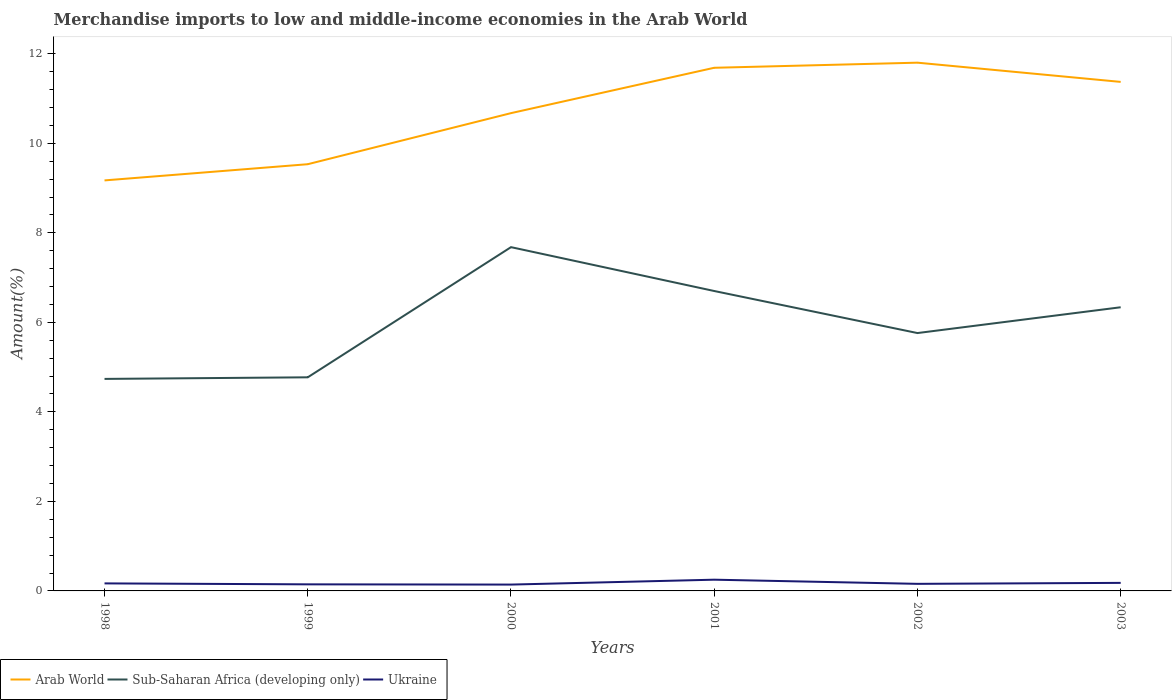How many different coloured lines are there?
Keep it short and to the point. 3. Is the number of lines equal to the number of legend labels?
Offer a very short reply. Yes. Across all years, what is the maximum percentage of amount earned from merchandise imports in Sub-Saharan Africa (developing only)?
Provide a succinct answer. 4.74. In which year was the percentage of amount earned from merchandise imports in Ukraine maximum?
Offer a very short reply. 2000. What is the total percentage of amount earned from merchandise imports in Ukraine in the graph?
Make the answer very short. -0.11. What is the difference between the highest and the second highest percentage of amount earned from merchandise imports in Arab World?
Offer a terse response. 2.63. What is the difference between the highest and the lowest percentage of amount earned from merchandise imports in Ukraine?
Your answer should be very brief. 2. Is the percentage of amount earned from merchandise imports in Arab World strictly greater than the percentage of amount earned from merchandise imports in Ukraine over the years?
Ensure brevity in your answer.  No. How many lines are there?
Give a very brief answer. 3. Are the values on the major ticks of Y-axis written in scientific E-notation?
Offer a terse response. No. Does the graph contain any zero values?
Ensure brevity in your answer.  No. What is the title of the graph?
Provide a succinct answer. Merchandise imports to low and middle-income economies in the Arab World. What is the label or title of the X-axis?
Your answer should be very brief. Years. What is the label or title of the Y-axis?
Offer a very short reply. Amount(%). What is the Amount(%) in Arab World in 1998?
Offer a terse response. 9.17. What is the Amount(%) in Sub-Saharan Africa (developing only) in 1998?
Your answer should be very brief. 4.74. What is the Amount(%) of Ukraine in 1998?
Give a very brief answer. 0.17. What is the Amount(%) of Arab World in 1999?
Offer a terse response. 9.53. What is the Amount(%) in Sub-Saharan Africa (developing only) in 1999?
Give a very brief answer. 4.77. What is the Amount(%) in Ukraine in 1999?
Offer a terse response. 0.15. What is the Amount(%) of Arab World in 2000?
Offer a terse response. 10.68. What is the Amount(%) of Sub-Saharan Africa (developing only) in 2000?
Make the answer very short. 7.68. What is the Amount(%) in Ukraine in 2000?
Your answer should be compact. 0.14. What is the Amount(%) of Arab World in 2001?
Provide a short and direct response. 11.69. What is the Amount(%) of Sub-Saharan Africa (developing only) in 2001?
Keep it short and to the point. 6.7. What is the Amount(%) of Ukraine in 2001?
Ensure brevity in your answer.  0.25. What is the Amount(%) in Arab World in 2002?
Offer a very short reply. 11.8. What is the Amount(%) of Sub-Saharan Africa (developing only) in 2002?
Your answer should be very brief. 5.76. What is the Amount(%) in Ukraine in 2002?
Give a very brief answer. 0.16. What is the Amount(%) in Arab World in 2003?
Your response must be concise. 11.37. What is the Amount(%) in Sub-Saharan Africa (developing only) in 2003?
Your answer should be very brief. 6.34. What is the Amount(%) in Ukraine in 2003?
Ensure brevity in your answer.  0.18. Across all years, what is the maximum Amount(%) in Arab World?
Offer a terse response. 11.8. Across all years, what is the maximum Amount(%) of Sub-Saharan Africa (developing only)?
Offer a terse response. 7.68. Across all years, what is the maximum Amount(%) in Ukraine?
Give a very brief answer. 0.25. Across all years, what is the minimum Amount(%) of Arab World?
Your response must be concise. 9.17. Across all years, what is the minimum Amount(%) in Sub-Saharan Africa (developing only)?
Give a very brief answer. 4.74. Across all years, what is the minimum Amount(%) in Ukraine?
Your answer should be compact. 0.14. What is the total Amount(%) of Arab World in the graph?
Provide a succinct answer. 64.25. What is the total Amount(%) in Sub-Saharan Africa (developing only) in the graph?
Give a very brief answer. 35.99. What is the total Amount(%) of Ukraine in the graph?
Your answer should be compact. 1.05. What is the difference between the Amount(%) of Arab World in 1998 and that in 1999?
Your answer should be very brief. -0.36. What is the difference between the Amount(%) of Sub-Saharan Africa (developing only) in 1998 and that in 1999?
Your answer should be very brief. -0.04. What is the difference between the Amount(%) in Ukraine in 1998 and that in 1999?
Offer a very short reply. 0.02. What is the difference between the Amount(%) of Arab World in 1998 and that in 2000?
Give a very brief answer. -1.5. What is the difference between the Amount(%) of Sub-Saharan Africa (developing only) in 1998 and that in 2000?
Make the answer very short. -2.94. What is the difference between the Amount(%) in Ukraine in 1998 and that in 2000?
Offer a terse response. 0.03. What is the difference between the Amount(%) in Arab World in 1998 and that in 2001?
Your answer should be compact. -2.52. What is the difference between the Amount(%) in Sub-Saharan Africa (developing only) in 1998 and that in 2001?
Offer a very short reply. -1.96. What is the difference between the Amount(%) of Ukraine in 1998 and that in 2001?
Your answer should be compact. -0.08. What is the difference between the Amount(%) of Arab World in 1998 and that in 2002?
Offer a very short reply. -2.63. What is the difference between the Amount(%) in Sub-Saharan Africa (developing only) in 1998 and that in 2002?
Give a very brief answer. -1.02. What is the difference between the Amount(%) of Ukraine in 1998 and that in 2002?
Give a very brief answer. 0.01. What is the difference between the Amount(%) of Arab World in 1998 and that in 2003?
Your answer should be very brief. -2.2. What is the difference between the Amount(%) of Sub-Saharan Africa (developing only) in 1998 and that in 2003?
Your answer should be very brief. -1.6. What is the difference between the Amount(%) in Ukraine in 1998 and that in 2003?
Provide a short and direct response. -0.01. What is the difference between the Amount(%) of Arab World in 1999 and that in 2000?
Offer a terse response. -1.14. What is the difference between the Amount(%) of Sub-Saharan Africa (developing only) in 1999 and that in 2000?
Your response must be concise. -2.91. What is the difference between the Amount(%) of Ukraine in 1999 and that in 2000?
Keep it short and to the point. 0.01. What is the difference between the Amount(%) in Arab World in 1999 and that in 2001?
Your answer should be very brief. -2.15. What is the difference between the Amount(%) of Sub-Saharan Africa (developing only) in 1999 and that in 2001?
Your response must be concise. -1.93. What is the difference between the Amount(%) in Ukraine in 1999 and that in 2001?
Your response must be concise. -0.1. What is the difference between the Amount(%) in Arab World in 1999 and that in 2002?
Your answer should be compact. -2.27. What is the difference between the Amount(%) of Sub-Saharan Africa (developing only) in 1999 and that in 2002?
Give a very brief answer. -0.99. What is the difference between the Amount(%) in Ukraine in 1999 and that in 2002?
Make the answer very short. -0.01. What is the difference between the Amount(%) in Arab World in 1999 and that in 2003?
Your answer should be very brief. -1.84. What is the difference between the Amount(%) in Sub-Saharan Africa (developing only) in 1999 and that in 2003?
Ensure brevity in your answer.  -1.57. What is the difference between the Amount(%) of Ukraine in 1999 and that in 2003?
Your answer should be very brief. -0.03. What is the difference between the Amount(%) of Arab World in 2000 and that in 2001?
Offer a terse response. -1.01. What is the difference between the Amount(%) of Sub-Saharan Africa (developing only) in 2000 and that in 2001?
Provide a succinct answer. 0.98. What is the difference between the Amount(%) in Ukraine in 2000 and that in 2001?
Keep it short and to the point. -0.11. What is the difference between the Amount(%) of Arab World in 2000 and that in 2002?
Your response must be concise. -1.13. What is the difference between the Amount(%) of Sub-Saharan Africa (developing only) in 2000 and that in 2002?
Offer a very short reply. 1.92. What is the difference between the Amount(%) of Ukraine in 2000 and that in 2002?
Provide a short and direct response. -0.02. What is the difference between the Amount(%) of Arab World in 2000 and that in 2003?
Your answer should be very brief. -0.7. What is the difference between the Amount(%) of Sub-Saharan Africa (developing only) in 2000 and that in 2003?
Provide a short and direct response. 1.34. What is the difference between the Amount(%) of Ukraine in 2000 and that in 2003?
Your answer should be very brief. -0.04. What is the difference between the Amount(%) of Arab World in 2001 and that in 2002?
Keep it short and to the point. -0.11. What is the difference between the Amount(%) of Sub-Saharan Africa (developing only) in 2001 and that in 2002?
Your answer should be very brief. 0.94. What is the difference between the Amount(%) in Ukraine in 2001 and that in 2002?
Ensure brevity in your answer.  0.09. What is the difference between the Amount(%) of Arab World in 2001 and that in 2003?
Your answer should be compact. 0.32. What is the difference between the Amount(%) in Sub-Saharan Africa (developing only) in 2001 and that in 2003?
Make the answer very short. 0.36. What is the difference between the Amount(%) of Ukraine in 2001 and that in 2003?
Offer a very short reply. 0.07. What is the difference between the Amount(%) of Arab World in 2002 and that in 2003?
Give a very brief answer. 0.43. What is the difference between the Amount(%) of Sub-Saharan Africa (developing only) in 2002 and that in 2003?
Provide a succinct answer. -0.58. What is the difference between the Amount(%) of Ukraine in 2002 and that in 2003?
Ensure brevity in your answer.  -0.02. What is the difference between the Amount(%) of Arab World in 1998 and the Amount(%) of Sub-Saharan Africa (developing only) in 1999?
Offer a terse response. 4.4. What is the difference between the Amount(%) in Arab World in 1998 and the Amount(%) in Ukraine in 1999?
Provide a short and direct response. 9.03. What is the difference between the Amount(%) of Sub-Saharan Africa (developing only) in 1998 and the Amount(%) of Ukraine in 1999?
Provide a short and direct response. 4.59. What is the difference between the Amount(%) of Arab World in 1998 and the Amount(%) of Sub-Saharan Africa (developing only) in 2000?
Your answer should be compact. 1.49. What is the difference between the Amount(%) of Arab World in 1998 and the Amount(%) of Ukraine in 2000?
Provide a short and direct response. 9.03. What is the difference between the Amount(%) of Sub-Saharan Africa (developing only) in 1998 and the Amount(%) of Ukraine in 2000?
Provide a succinct answer. 4.6. What is the difference between the Amount(%) of Arab World in 1998 and the Amount(%) of Sub-Saharan Africa (developing only) in 2001?
Your answer should be very brief. 2.47. What is the difference between the Amount(%) of Arab World in 1998 and the Amount(%) of Ukraine in 2001?
Make the answer very short. 8.92. What is the difference between the Amount(%) of Sub-Saharan Africa (developing only) in 1998 and the Amount(%) of Ukraine in 2001?
Your answer should be very brief. 4.49. What is the difference between the Amount(%) in Arab World in 1998 and the Amount(%) in Sub-Saharan Africa (developing only) in 2002?
Your response must be concise. 3.41. What is the difference between the Amount(%) of Arab World in 1998 and the Amount(%) of Ukraine in 2002?
Provide a succinct answer. 9.01. What is the difference between the Amount(%) of Sub-Saharan Africa (developing only) in 1998 and the Amount(%) of Ukraine in 2002?
Keep it short and to the point. 4.58. What is the difference between the Amount(%) in Arab World in 1998 and the Amount(%) in Sub-Saharan Africa (developing only) in 2003?
Offer a very short reply. 2.83. What is the difference between the Amount(%) of Arab World in 1998 and the Amount(%) of Ukraine in 2003?
Provide a succinct answer. 8.99. What is the difference between the Amount(%) in Sub-Saharan Africa (developing only) in 1998 and the Amount(%) in Ukraine in 2003?
Provide a short and direct response. 4.56. What is the difference between the Amount(%) in Arab World in 1999 and the Amount(%) in Sub-Saharan Africa (developing only) in 2000?
Your answer should be compact. 1.85. What is the difference between the Amount(%) of Arab World in 1999 and the Amount(%) of Ukraine in 2000?
Provide a short and direct response. 9.39. What is the difference between the Amount(%) in Sub-Saharan Africa (developing only) in 1999 and the Amount(%) in Ukraine in 2000?
Offer a very short reply. 4.63. What is the difference between the Amount(%) in Arab World in 1999 and the Amount(%) in Sub-Saharan Africa (developing only) in 2001?
Keep it short and to the point. 2.83. What is the difference between the Amount(%) of Arab World in 1999 and the Amount(%) of Ukraine in 2001?
Keep it short and to the point. 9.28. What is the difference between the Amount(%) in Sub-Saharan Africa (developing only) in 1999 and the Amount(%) in Ukraine in 2001?
Offer a very short reply. 4.52. What is the difference between the Amount(%) in Arab World in 1999 and the Amount(%) in Sub-Saharan Africa (developing only) in 2002?
Offer a terse response. 3.77. What is the difference between the Amount(%) of Arab World in 1999 and the Amount(%) of Ukraine in 2002?
Ensure brevity in your answer.  9.38. What is the difference between the Amount(%) of Sub-Saharan Africa (developing only) in 1999 and the Amount(%) of Ukraine in 2002?
Give a very brief answer. 4.61. What is the difference between the Amount(%) of Arab World in 1999 and the Amount(%) of Sub-Saharan Africa (developing only) in 2003?
Your answer should be very brief. 3.2. What is the difference between the Amount(%) in Arab World in 1999 and the Amount(%) in Ukraine in 2003?
Make the answer very short. 9.35. What is the difference between the Amount(%) of Sub-Saharan Africa (developing only) in 1999 and the Amount(%) of Ukraine in 2003?
Give a very brief answer. 4.59. What is the difference between the Amount(%) of Arab World in 2000 and the Amount(%) of Sub-Saharan Africa (developing only) in 2001?
Provide a succinct answer. 3.97. What is the difference between the Amount(%) in Arab World in 2000 and the Amount(%) in Ukraine in 2001?
Give a very brief answer. 10.42. What is the difference between the Amount(%) in Sub-Saharan Africa (developing only) in 2000 and the Amount(%) in Ukraine in 2001?
Give a very brief answer. 7.43. What is the difference between the Amount(%) in Arab World in 2000 and the Amount(%) in Sub-Saharan Africa (developing only) in 2002?
Offer a terse response. 4.91. What is the difference between the Amount(%) in Arab World in 2000 and the Amount(%) in Ukraine in 2002?
Make the answer very short. 10.52. What is the difference between the Amount(%) of Sub-Saharan Africa (developing only) in 2000 and the Amount(%) of Ukraine in 2002?
Offer a very short reply. 7.52. What is the difference between the Amount(%) in Arab World in 2000 and the Amount(%) in Sub-Saharan Africa (developing only) in 2003?
Make the answer very short. 4.34. What is the difference between the Amount(%) in Arab World in 2000 and the Amount(%) in Ukraine in 2003?
Provide a succinct answer. 10.5. What is the difference between the Amount(%) in Sub-Saharan Africa (developing only) in 2000 and the Amount(%) in Ukraine in 2003?
Offer a terse response. 7.5. What is the difference between the Amount(%) in Arab World in 2001 and the Amount(%) in Sub-Saharan Africa (developing only) in 2002?
Your answer should be compact. 5.93. What is the difference between the Amount(%) in Arab World in 2001 and the Amount(%) in Ukraine in 2002?
Ensure brevity in your answer.  11.53. What is the difference between the Amount(%) of Sub-Saharan Africa (developing only) in 2001 and the Amount(%) of Ukraine in 2002?
Provide a succinct answer. 6.54. What is the difference between the Amount(%) in Arab World in 2001 and the Amount(%) in Sub-Saharan Africa (developing only) in 2003?
Your response must be concise. 5.35. What is the difference between the Amount(%) of Arab World in 2001 and the Amount(%) of Ukraine in 2003?
Make the answer very short. 11.51. What is the difference between the Amount(%) in Sub-Saharan Africa (developing only) in 2001 and the Amount(%) in Ukraine in 2003?
Give a very brief answer. 6.52. What is the difference between the Amount(%) of Arab World in 2002 and the Amount(%) of Sub-Saharan Africa (developing only) in 2003?
Give a very brief answer. 5.46. What is the difference between the Amount(%) in Arab World in 2002 and the Amount(%) in Ukraine in 2003?
Your response must be concise. 11.62. What is the difference between the Amount(%) of Sub-Saharan Africa (developing only) in 2002 and the Amount(%) of Ukraine in 2003?
Your response must be concise. 5.58. What is the average Amount(%) in Arab World per year?
Give a very brief answer. 10.71. What is the average Amount(%) of Sub-Saharan Africa (developing only) per year?
Give a very brief answer. 6. What is the average Amount(%) of Ukraine per year?
Give a very brief answer. 0.17. In the year 1998, what is the difference between the Amount(%) in Arab World and Amount(%) in Sub-Saharan Africa (developing only)?
Give a very brief answer. 4.44. In the year 1998, what is the difference between the Amount(%) of Arab World and Amount(%) of Ukraine?
Your answer should be very brief. 9. In the year 1998, what is the difference between the Amount(%) in Sub-Saharan Africa (developing only) and Amount(%) in Ukraine?
Offer a very short reply. 4.57. In the year 1999, what is the difference between the Amount(%) of Arab World and Amount(%) of Sub-Saharan Africa (developing only)?
Make the answer very short. 4.76. In the year 1999, what is the difference between the Amount(%) of Arab World and Amount(%) of Ukraine?
Your answer should be very brief. 9.39. In the year 1999, what is the difference between the Amount(%) in Sub-Saharan Africa (developing only) and Amount(%) in Ukraine?
Your answer should be very brief. 4.63. In the year 2000, what is the difference between the Amount(%) in Arab World and Amount(%) in Sub-Saharan Africa (developing only)?
Your answer should be very brief. 2.99. In the year 2000, what is the difference between the Amount(%) in Arab World and Amount(%) in Ukraine?
Make the answer very short. 10.53. In the year 2000, what is the difference between the Amount(%) in Sub-Saharan Africa (developing only) and Amount(%) in Ukraine?
Provide a succinct answer. 7.54. In the year 2001, what is the difference between the Amount(%) in Arab World and Amount(%) in Sub-Saharan Africa (developing only)?
Offer a terse response. 4.99. In the year 2001, what is the difference between the Amount(%) in Arab World and Amount(%) in Ukraine?
Provide a succinct answer. 11.44. In the year 2001, what is the difference between the Amount(%) in Sub-Saharan Africa (developing only) and Amount(%) in Ukraine?
Give a very brief answer. 6.45. In the year 2002, what is the difference between the Amount(%) in Arab World and Amount(%) in Sub-Saharan Africa (developing only)?
Offer a terse response. 6.04. In the year 2002, what is the difference between the Amount(%) in Arab World and Amount(%) in Ukraine?
Provide a short and direct response. 11.64. In the year 2002, what is the difference between the Amount(%) in Sub-Saharan Africa (developing only) and Amount(%) in Ukraine?
Provide a short and direct response. 5.6. In the year 2003, what is the difference between the Amount(%) of Arab World and Amount(%) of Sub-Saharan Africa (developing only)?
Make the answer very short. 5.04. In the year 2003, what is the difference between the Amount(%) in Arab World and Amount(%) in Ukraine?
Make the answer very short. 11.19. In the year 2003, what is the difference between the Amount(%) in Sub-Saharan Africa (developing only) and Amount(%) in Ukraine?
Provide a succinct answer. 6.16. What is the ratio of the Amount(%) in Sub-Saharan Africa (developing only) in 1998 to that in 1999?
Make the answer very short. 0.99. What is the ratio of the Amount(%) of Ukraine in 1998 to that in 1999?
Your answer should be compact. 1.15. What is the ratio of the Amount(%) of Arab World in 1998 to that in 2000?
Offer a terse response. 0.86. What is the ratio of the Amount(%) of Sub-Saharan Africa (developing only) in 1998 to that in 2000?
Give a very brief answer. 0.62. What is the ratio of the Amount(%) in Ukraine in 1998 to that in 2000?
Ensure brevity in your answer.  1.19. What is the ratio of the Amount(%) in Arab World in 1998 to that in 2001?
Give a very brief answer. 0.78. What is the ratio of the Amount(%) of Sub-Saharan Africa (developing only) in 1998 to that in 2001?
Provide a short and direct response. 0.71. What is the ratio of the Amount(%) in Ukraine in 1998 to that in 2001?
Offer a terse response. 0.67. What is the ratio of the Amount(%) of Arab World in 1998 to that in 2002?
Offer a terse response. 0.78. What is the ratio of the Amount(%) of Sub-Saharan Africa (developing only) in 1998 to that in 2002?
Your answer should be compact. 0.82. What is the ratio of the Amount(%) of Ukraine in 1998 to that in 2002?
Keep it short and to the point. 1.06. What is the ratio of the Amount(%) of Arab World in 1998 to that in 2003?
Keep it short and to the point. 0.81. What is the ratio of the Amount(%) of Sub-Saharan Africa (developing only) in 1998 to that in 2003?
Offer a terse response. 0.75. What is the ratio of the Amount(%) in Ukraine in 1998 to that in 2003?
Provide a short and direct response. 0.94. What is the ratio of the Amount(%) in Arab World in 1999 to that in 2000?
Your answer should be very brief. 0.89. What is the ratio of the Amount(%) of Sub-Saharan Africa (developing only) in 1999 to that in 2000?
Provide a short and direct response. 0.62. What is the ratio of the Amount(%) in Ukraine in 1999 to that in 2000?
Ensure brevity in your answer.  1.04. What is the ratio of the Amount(%) in Arab World in 1999 to that in 2001?
Offer a terse response. 0.82. What is the ratio of the Amount(%) in Sub-Saharan Africa (developing only) in 1999 to that in 2001?
Your answer should be very brief. 0.71. What is the ratio of the Amount(%) of Ukraine in 1999 to that in 2001?
Your answer should be very brief. 0.58. What is the ratio of the Amount(%) of Arab World in 1999 to that in 2002?
Offer a terse response. 0.81. What is the ratio of the Amount(%) in Sub-Saharan Africa (developing only) in 1999 to that in 2002?
Your answer should be very brief. 0.83. What is the ratio of the Amount(%) in Ukraine in 1999 to that in 2002?
Give a very brief answer. 0.93. What is the ratio of the Amount(%) of Arab World in 1999 to that in 2003?
Your answer should be very brief. 0.84. What is the ratio of the Amount(%) in Sub-Saharan Africa (developing only) in 1999 to that in 2003?
Your response must be concise. 0.75. What is the ratio of the Amount(%) of Ukraine in 1999 to that in 2003?
Your answer should be very brief. 0.82. What is the ratio of the Amount(%) in Arab World in 2000 to that in 2001?
Your answer should be compact. 0.91. What is the ratio of the Amount(%) of Sub-Saharan Africa (developing only) in 2000 to that in 2001?
Your answer should be compact. 1.15. What is the ratio of the Amount(%) in Ukraine in 2000 to that in 2001?
Offer a terse response. 0.57. What is the ratio of the Amount(%) in Arab World in 2000 to that in 2002?
Keep it short and to the point. 0.9. What is the ratio of the Amount(%) in Sub-Saharan Africa (developing only) in 2000 to that in 2002?
Provide a short and direct response. 1.33. What is the ratio of the Amount(%) in Ukraine in 2000 to that in 2002?
Make the answer very short. 0.9. What is the ratio of the Amount(%) of Arab World in 2000 to that in 2003?
Ensure brevity in your answer.  0.94. What is the ratio of the Amount(%) in Sub-Saharan Africa (developing only) in 2000 to that in 2003?
Offer a terse response. 1.21. What is the ratio of the Amount(%) in Ukraine in 2000 to that in 2003?
Make the answer very short. 0.79. What is the ratio of the Amount(%) in Arab World in 2001 to that in 2002?
Provide a succinct answer. 0.99. What is the ratio of the Amount(%) in Sub-Saharan Africa (developing only) in 2001 to that in 2002?
Offer a terse response. 1.16. What is the ratio of the Amount(%) in Ukraine in 2001 to that in 2002?
Ensure brevity in your answer.  1.59. What is the ratio of the Amount(%) of Arab World in 2001 to that in 2003?
Give a very brief answer. 1.03. What is the ratio of the Amount(%) of Sub-Saharan Africa (developing only) in 2001 to that in 2003?
Make the answer very short. 1.06. What is the ratio of the Amount(%) in Ukraine in 2001 to that in 2003?
Your response must be concise. 1.4. What is the ratio of the Amount(%) in Arab World in 2002 to that in 2003?
Offer a terse response. 1.04. What is the ratio of the Amount(%) of Sub-Saharan Africa (developing only) in 2002 to that in 2003?
Your response must be concise. 0.91. What is the ratio of the Amount(%) in Ukraine in 2002 to that in 2003?
Keep it short and to the point. 0.88. What is the difference between the highest and the second highest Amount(%) of Arab World?
Keep it short and to the point. 0.11. What is the difference between the highest and the second highest Amount(%) in Ukraine?
Provide a succinct answer. 0.07. What is the difference between the highest and the lowest Amount(%) in Arab World?
Offer a terse response. 2.63. What is the difference between the highest and the lowest Amount(%) in Sub-Saharan Africa (developing only)?
Keep it short and to the point. 2.94. What is the difference between the highest and the lowest Amount(%) in Ukraine?
Ensure brevity in your answer.  0.11. 